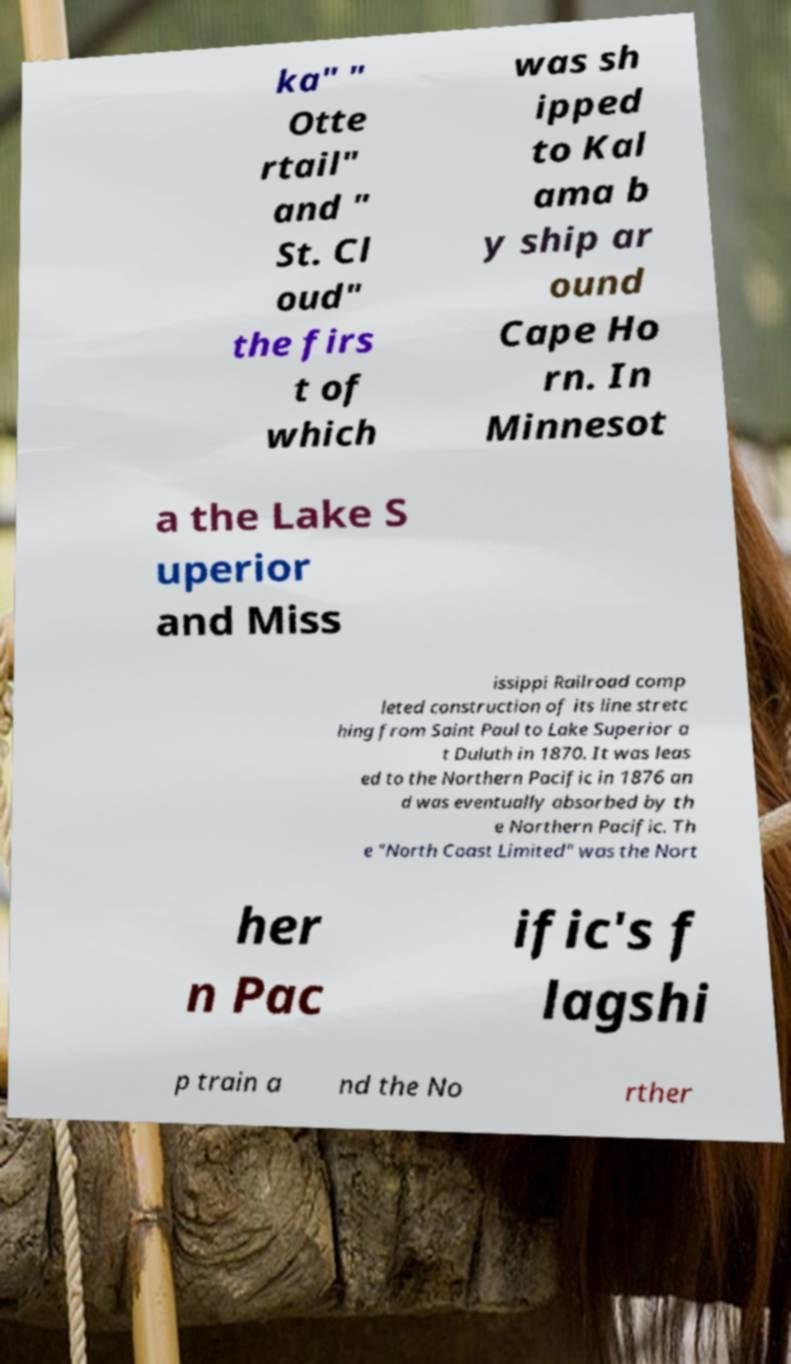I need the written content from this picture converted into text. Can you do that? ka" " Otte rtail" and " St. Cl oud" the firs t of which was sh ipped to Kal ama b y ship ar ound Cape Ho rn. In Minnesot a the Lake S uperior and Miss issippi Railroad comp leted construction of its line stretc hing from Saint Paul to Lake Superior a t Duluth in 1870. It was leas ed to the Northern Pacific in 1876 an d was eventually absorbed by th e Northern Pacific. Th e "North Coast Limited" was the Nort her n Pac ific's f lagshi p train a nd the No rther 